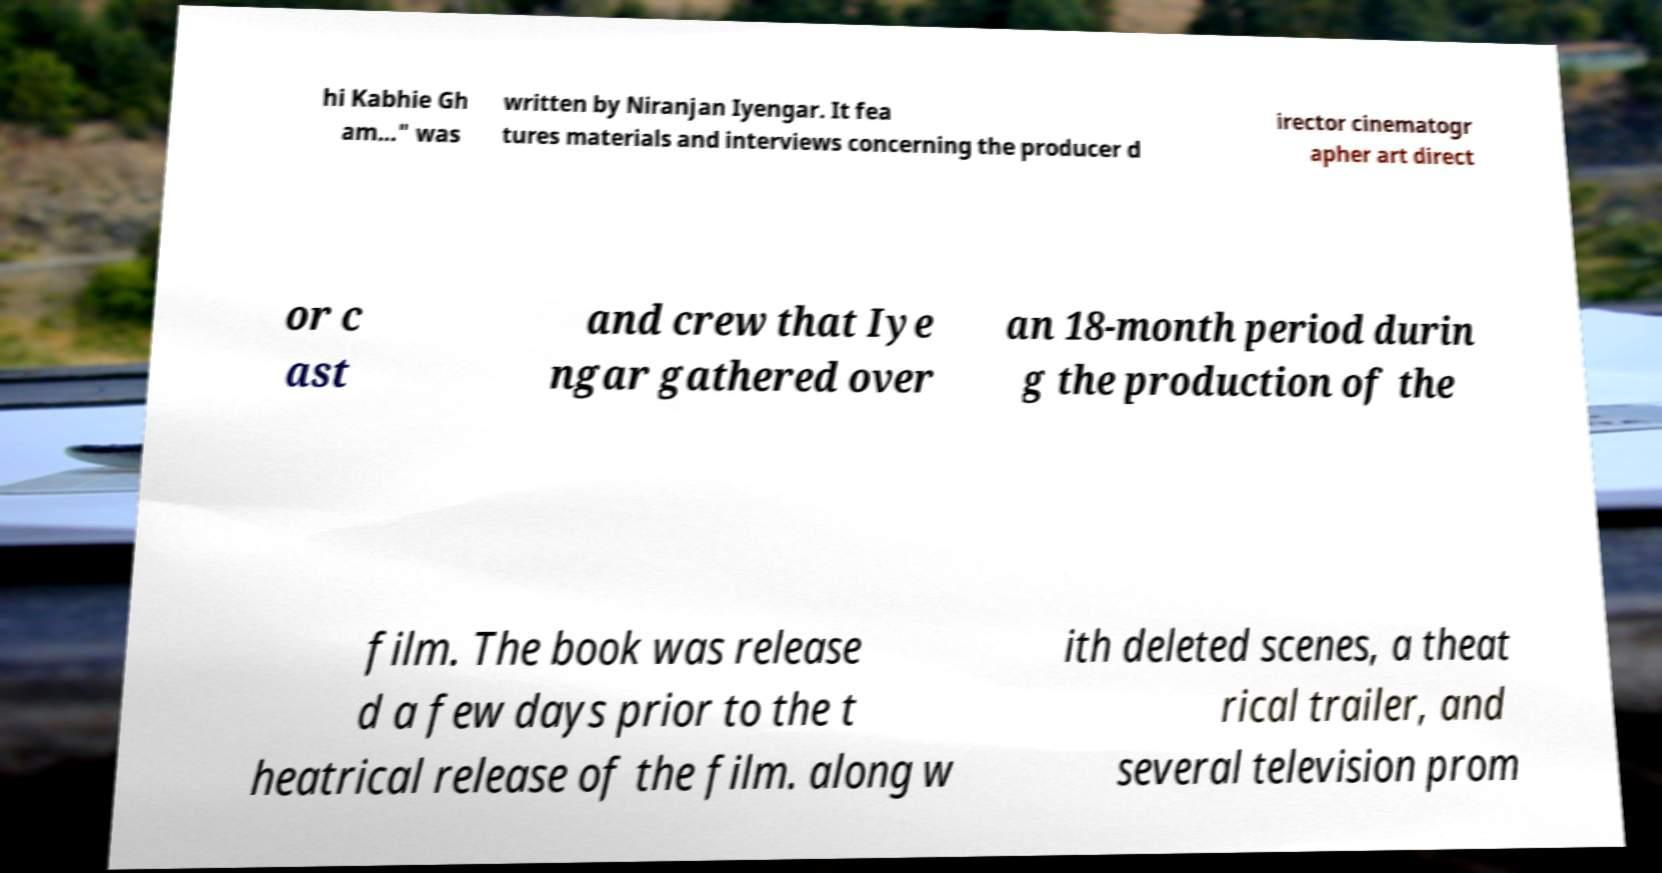There's text embedded in this image that I need extracted. Can you transcribe it verbatim? hi Kabhie Gh am..." was written by Niranjan Iyengar. It fea tures materials and interviews concerning the producer d irector cinematogr apher art direct or c ast and crew that Iye ngar gathered over an 18-month period durin g the production of the film. The book was release d a few days prior to the t heatrical release of the film. along w ith deleted scenes, a theat rical trailer, and several television prom 